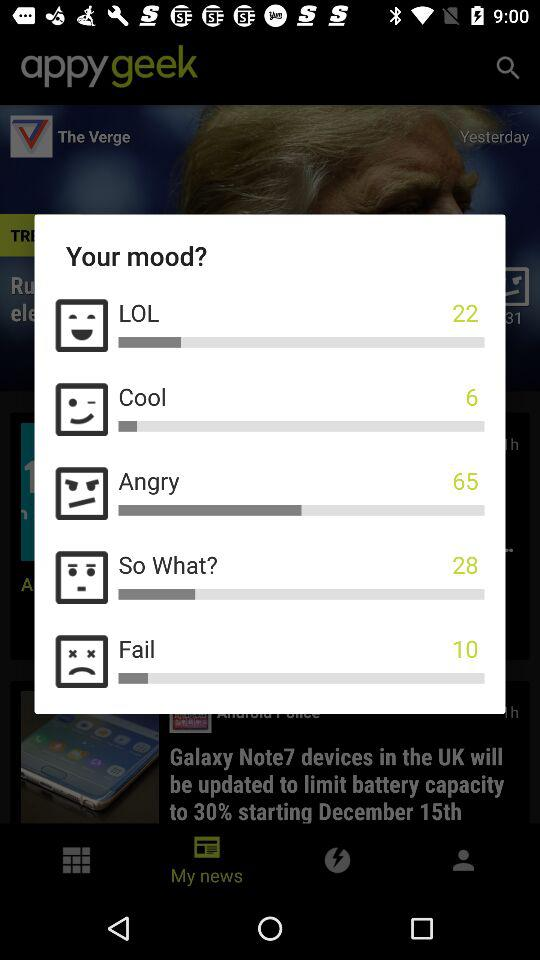Which mood got 22 votes? The mood that got 22 votes is LOL. 